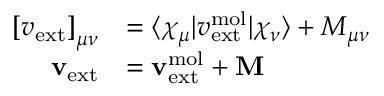<formula> <loc_0><loc_0><loc_500><loc_500>\begin{array} { r l } { \left [ v _ { e x t } \right ] _ { \mu \nu } } & { = \langle \chi _ { \mu } | v _ { e x t } ^ { m o l } | \chi _ { \nu } \rangle + M _ { \mu \nu } } \\ { v _ { e x t } } & { = v _ { e x t } ^ { m o l } + M } \end{array}</formula> 